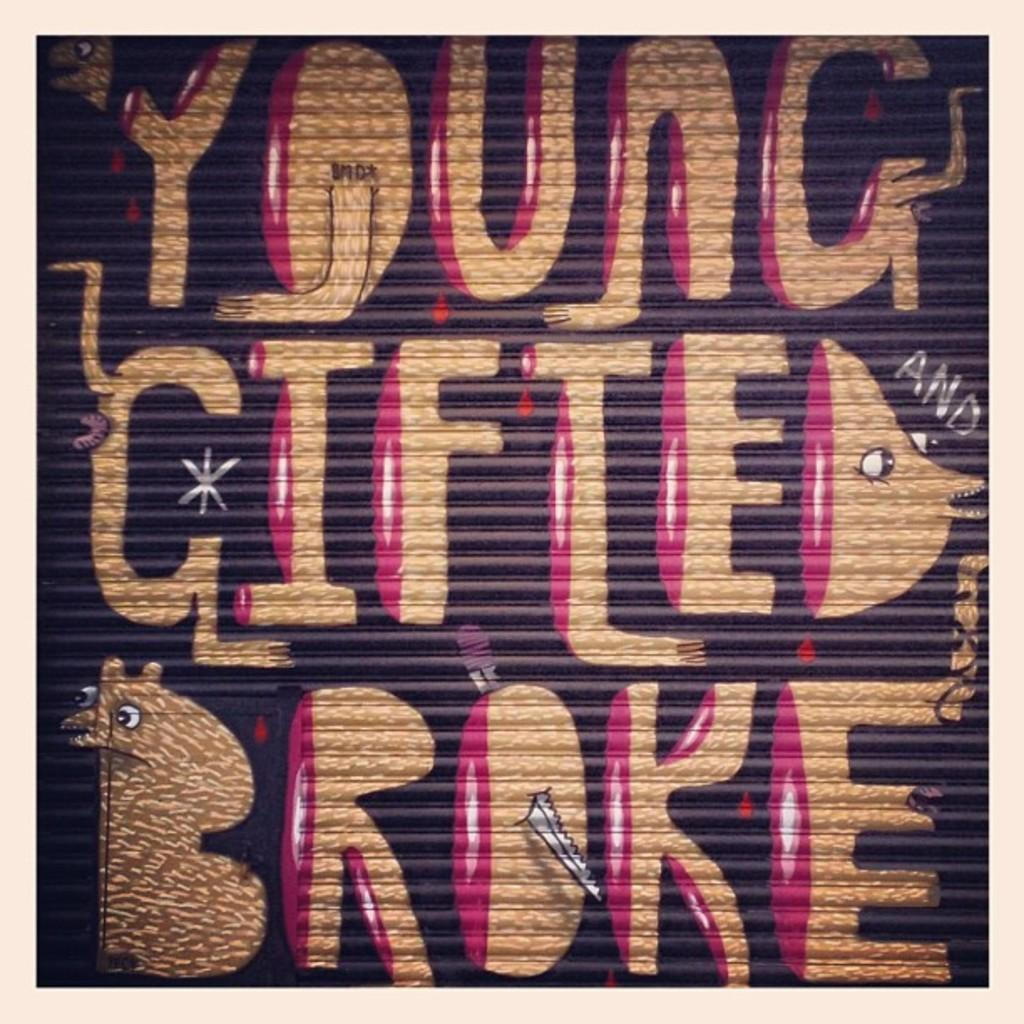What type of text is present in the image? There is colorful text in the image. Can you see any properties or gardens near the lake in the image? There is no lake, property, or garden present in the image; it only contains colorful text. 